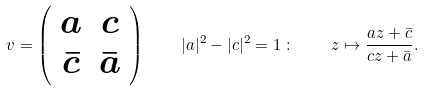Convert formula to latex. <formula><loc_0><loc_0><loc_500><loc_500>v = \left ( \begin{array} { c c } a & c \\ \bar { c } & \bar { a } \end{array} \right ) \quad | a | ^ { 2 } - | c | ^ { 2 } = 1 \, \colon \quad z \mapsto \frac { a z + \bar { c } } { c z + \bar { a } } .</formula> 